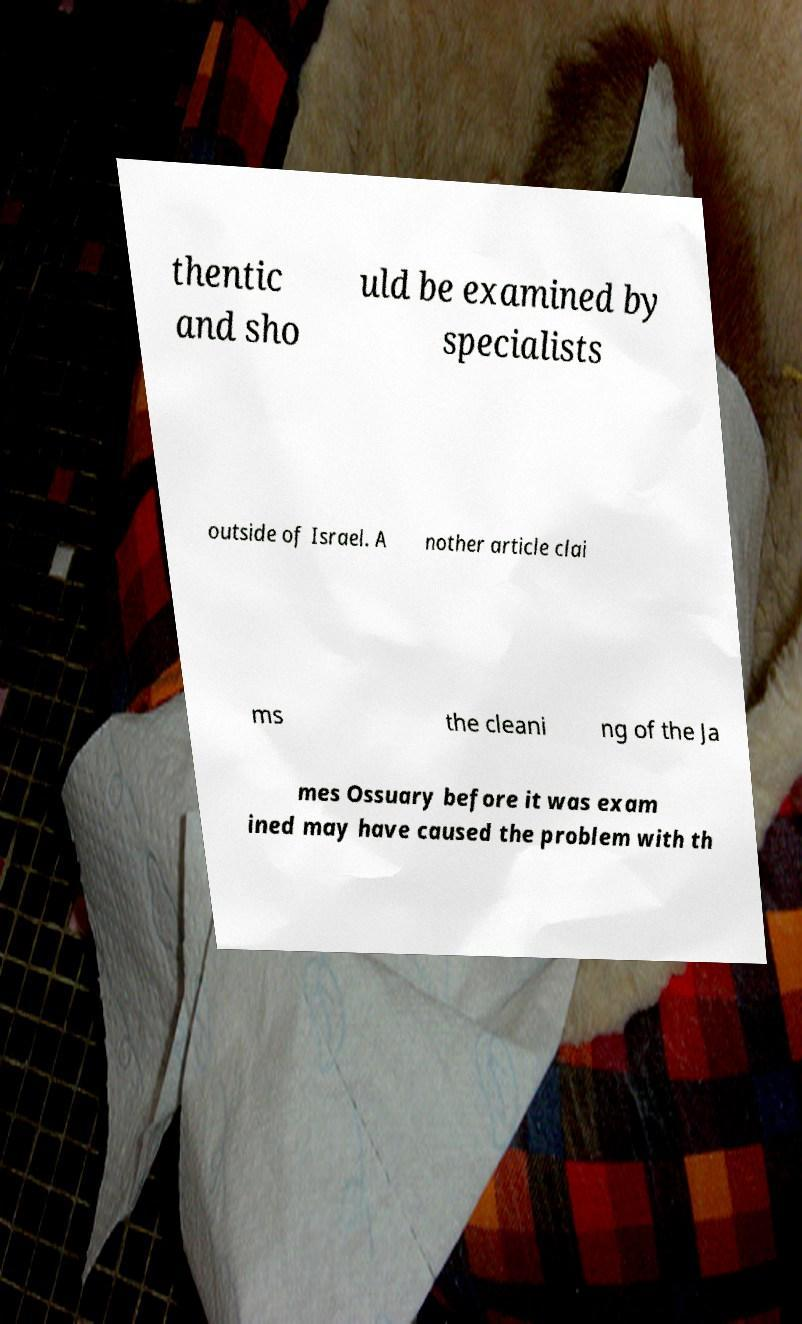There's text embedded in this image that I need extracted. Can you transcribe it verbatim? thentic and sho uld be examined by specialists outside of Israel. A nother article clai ms the cleani ng of the Ja mes Ossuary before it was exam ined may have caused the problem with th 